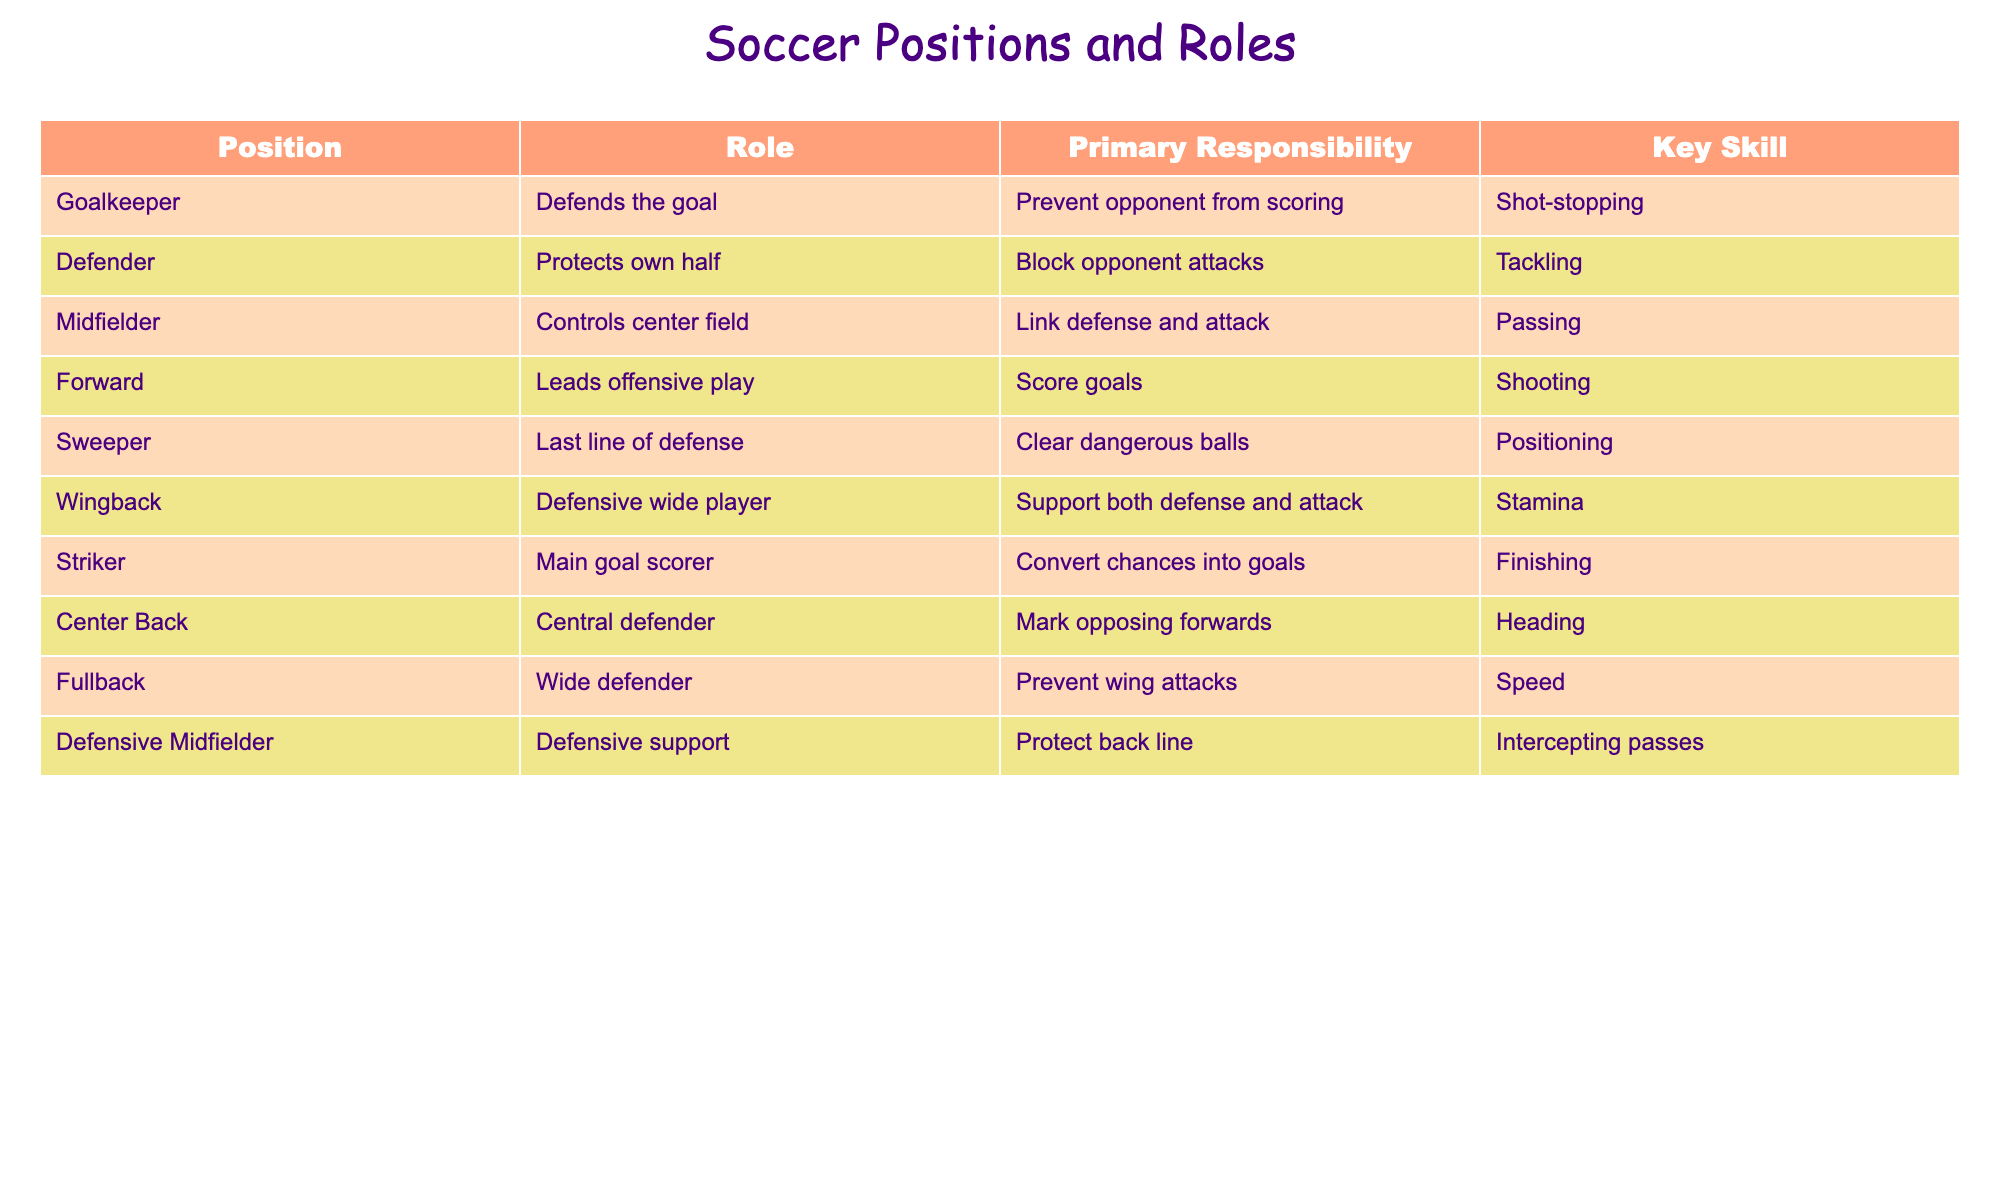What position is responsible for preventing the opponent from scoring? From the table, the role of "Goalkeeper" is explicitly described as "Defends the goal" and their primary responsibility is to "Prevent opponent from scoring."
Answer: Goalkeeper How many positional roles are focused on defense? The table lists three roles with a clear defensive focus: "Defender," "Sweeper," and "Fullback." Therefore, the total number of defensive roles is three.
Answer: 3 Is a Midfielder responsible for scoring goals? The "Midfielder" role is primarily about controlling center field and linking defense and attack. It does not specifically state scoring as a responsibility, so the answer is no.
Answer: No What is the key skill for a Striker? According to the table, the Striker's primary responsibility is to "Convert chances into goals," and their key skill is "Finishing."
Answer: Finishing Which position acts as the last line of defense? The "Sweeper" is identified in the table as the last line of defense, with the primary responsibility to "Clear dangerous balls."
Answer: Sweeper What is the overlap in skills between Wingback and Midfielder positions? The "Wingback" supports both defense and attack with "Stamina" as their key skill, similar to a "Midfielder" who links defense and attack through "Passing." While not the same skill, they both facilitate play between defense and offense.
Answer: Similar responsibilities; different key skills Which position is primarily responsible for heading the ball? The table shows that the "Center Back" has the responsibility to "Mark opposing forwards" and their key skill includes "Heading." This indicates that heading the ball mainly falls under this position.
Answer: Center Back If a team has three Defenders, how many positions are available to lead offensive plays? Without counting "Defenders," there are two roles focused specifically on offense: "Forward" and "Striker." Thus, if three defenders are present, offensive roles remain at two.
Answer: 2 Is Shot-stopping a key skill for a Defender? The table specifies that "Shot-stopping" is the key skill for the "Goalkeeper," not a "Defender." Therefore, it is false that "Shot-stopping" applies to Defenders.
Answer: No What is the main responsibility of a Defensive Midfielder compared to that of a Forward? The "Defensive Midfielder" focuses on protecting the back line, while the "Forward" leads offensive play to score goals. This highlights a clear difference in responsibilities.
Answer: Protect back line vs. score goals Which position requires stamina as a key skill? The table states that "Wingback" is the position that requires "Stamina" as a key skill, supporting both defense and attack.
Answer: Wingback 